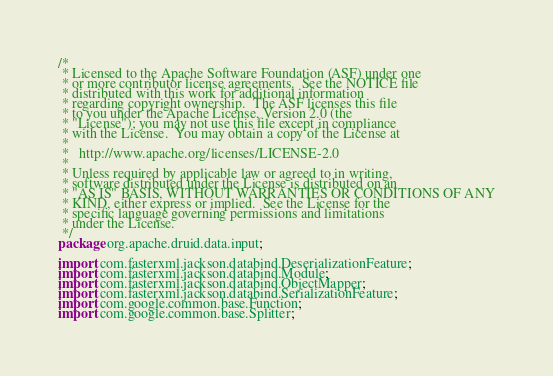<code> <loc_0><loc_0><loc_500><loc_500><_Java_>/*
 * Licensed to the Apache Software Foundation (ASF) under one
 * or more contributor license agreements.  See the NOTICE file
 * distributed with this work for additional information
 * regarding copyright ownership.  The ASF licenses this file
 * to you under the Apache License, Version 2.0 (the
 * "License"); you may not use this file except in compliance
 * with the License.  You may obtain a copy of the License at
 *
 *   http://www.apache.org/licenses/LICENSE-2.0
 *
 * Unless required by applicable law or agreed to in writing,
 * software distributed under the License is distributed on an
 * "AS IS" BASIS, WITHOUT WARRANTIES OR CONDITIONS OF ANY
 * KIND, either express or implied.  See the License for the
 * specific language governing permissions and limitations
 * under the License.
 */
package org.apache.druid.data.input;

import com.fasterxml.jackson.databind.DeserializationFeature;
import com.fasterxml.jackson.databind.Module;
import com.fasterxml.jackson.databind.ObjectMapper;
import com.fasterxml.jackson.databind.SerializationFeature;
import com.google.common.base.Function;
import com.google.common.base.Splitter;</code> 